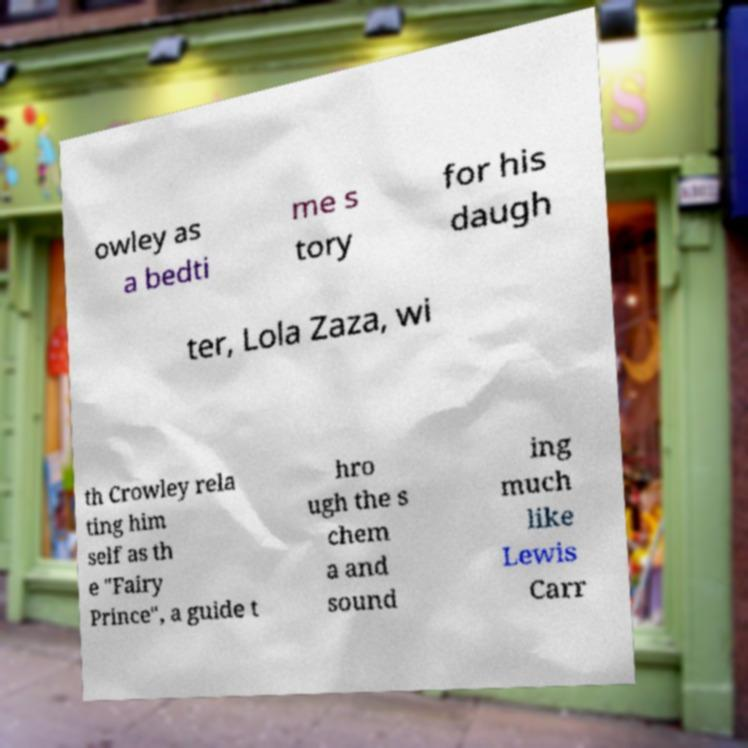What messages or text are displayed in this image? I need them in a readable, typed format. owley as a bedti me s tory for his daugh ter, Lola Zaza, wi th Crowley rela ting him self as th e "Fairy Prince", a guide t hro ugh the s chem a and sound ing much like Lewis Carr 